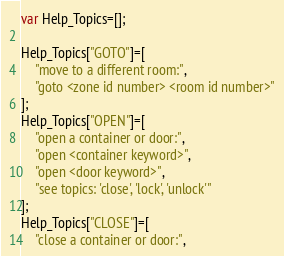<code> <loc_0><loc_0><loc_500><loc_500><_JavaScript_>var Help_Topics=[];

Help_Topics["GOTO"]=[
	"move to a different room:",
	"goto <zone id number> <room id number>"
];
Help_Topics["OPEN"]=[
	"open a container or door:",
	"open <container keyword>",
	"open <door keyword>",
	"see topics: 'close', 'lock', 'unlock'"
];
Help_Topics["CLOSE"]=[
	"close a container or door:",</code> 